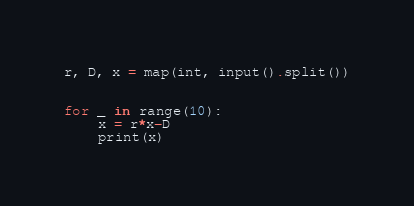<code> <loc_0><loc_0><loc_500><loc_500><_Python_>r, D, x = map(int, input().split())


for _ in range(10):
    x = r*x-D
    print(x)
</code> 